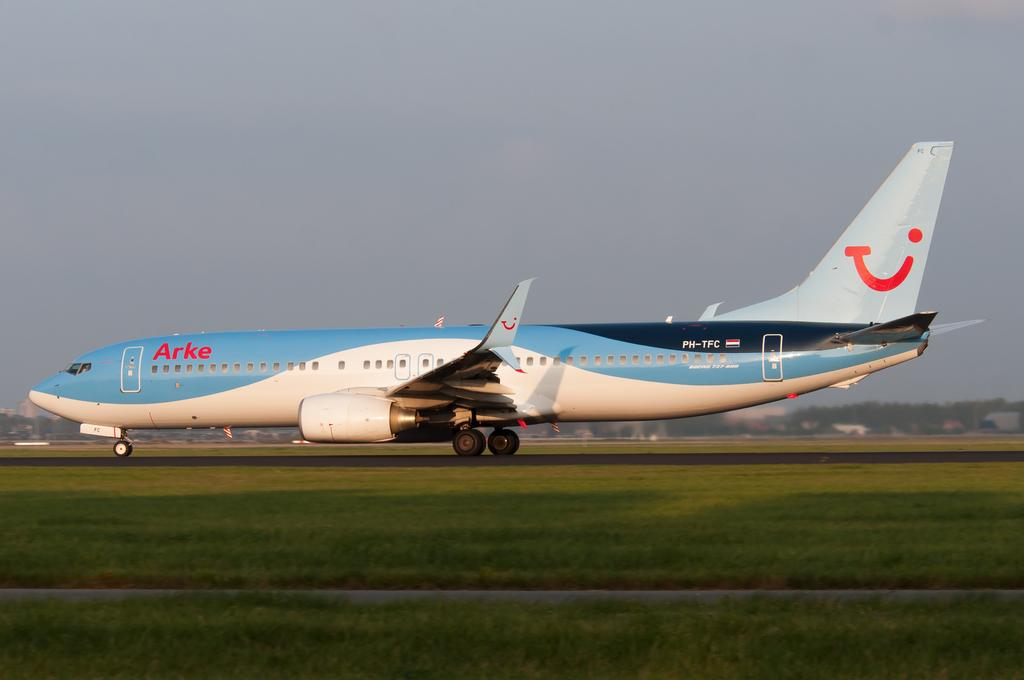<image>
Give a short and clear explanation of the subsequent image. the Arke plane has a smiling face on the tail 